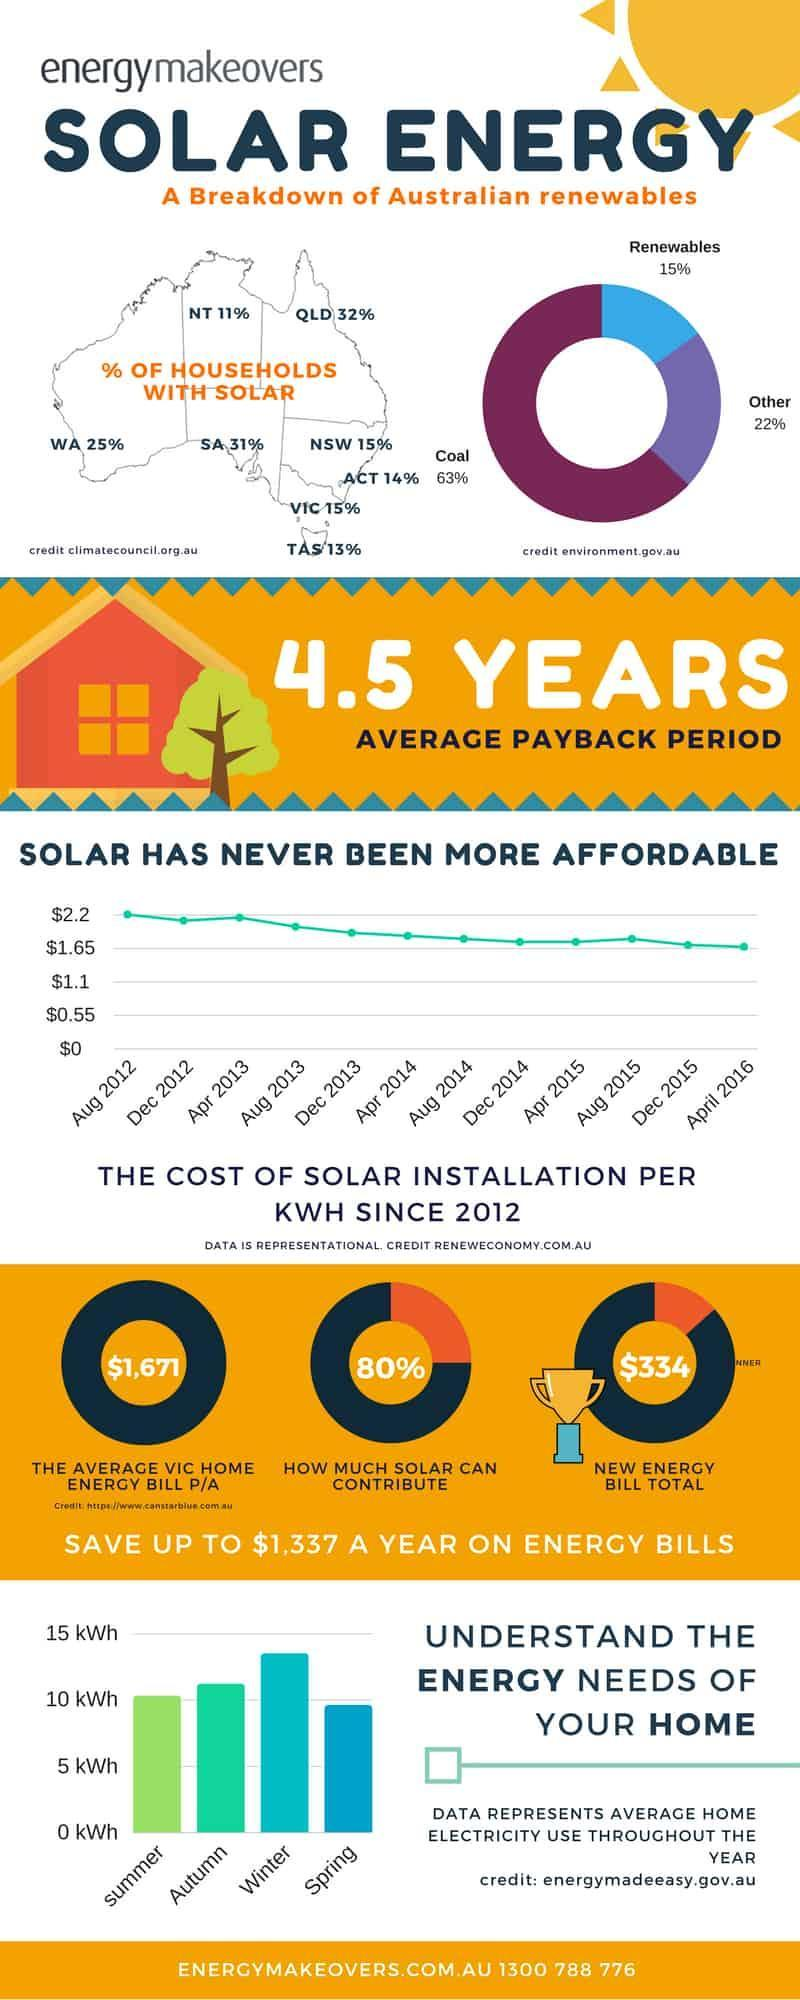During which season, the average home electricity use is the lowest?
Answer the question with a short phrase. Spring What is the percentage of households with solar in Western Australia? 25% Which year has the lowest cost of solar installation? April 2016 What is the cost of solar installation per KWH in Aug 2012? $2.2 During which season, the average home electricity use is the highest? Winter What percentage of renewable energy is used in Australia? 15% What is the percentage of households with solar in Victoria? 15% What is the new energy bill total? $334 